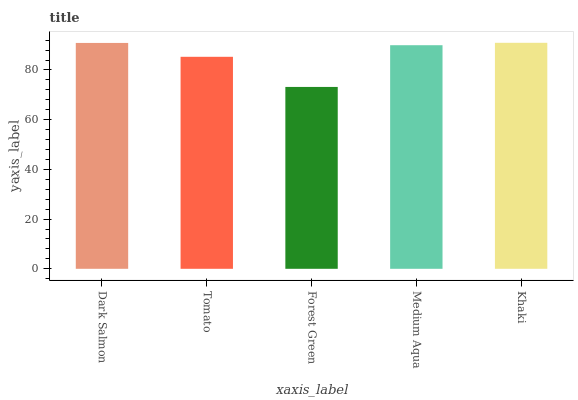Is Tomato the minimum?
Answer yes or no. No. Is Tomato the maximum?
Answer yes or no. No. Is Dark Salmon greater than Tomato?
Answer yes or no. Yes. Is Tomato less than Dark Salmon?
Answer yes or no. Yes. Is Tomato greater than Dark Salmon?
Answer yes or no. No. Is Dark Salmon less than Tomato?
Answer yes or no. No. Is Medium Aqua the high median?
Answer yes or no. Yes. Is Medium Aqua the low median?
Answer yes or no. Yes. Is Dark Salmon the high median?
Answer yes or no. No. Is Forest Green the low median?
Answer yes or no. No. 